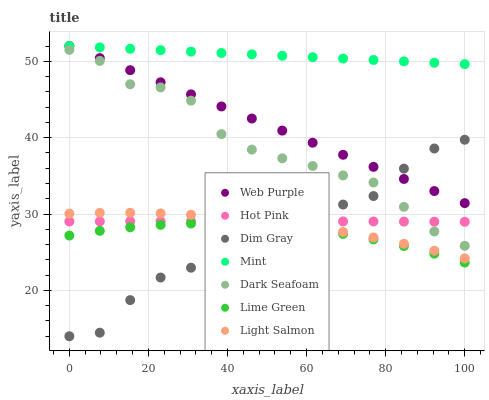Does Dim Gray have the minimum area under the curve?
Answer yes or no. Yes. Does Mint have the maximum area under the curve?
Answer yes or no. Yes. Does Mint have the minimum area under the curve?
Answer yes or no. No. Does Dim Gray have the maximum area under the curve?
Answer yes or no. No. Is Mint the smoothest?
Answer yes or no. Yes. Is Dim Gray the roughest?
Answer yes or no. Yes. Is Dim Gray the smoothest?
Answer yes or no. No. Is Mint the roughest?
Answer yes or no. No. Does Dim Gray have the lowest value?
Answer yes or no. Yes. Does Mint have the lowest value?
Answer yes or no. No. Does Web Purple have the highest value?
Answer yes or no. Yes. Does Dim Gray have the highest value?
Answer yes or no. No. Is Hot Pink less than Web Purple?
Answer yes or no. Yes. Is Web Purple greater than Lime Green?
Answer yes or no. Yes. Does Dim Gray intersect Dark Seafoam?
Answer yes or no. Yes. Is Dim Gray less than Dark Seafoam?
Answer yes or no. No. Is Dim Gray greater than Dark Seafoam?
Answer yes or no. No. Does Hot Pink intersect Web Purple?
Answer yes or no. No. 